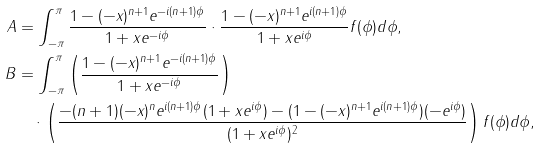Convert formula to latex. <formula><loc_0><loc_0><loc_500><loc_500>A & = \int _ { - \pi } ^ { \pi } \frac { 1 - ( - x ) ^ { n + 1 } e ^ { - i ( n + 1 ) \phi } } { 1 + x e ^ { - i \phi } } \cdot \frac { 1 - ( - x ) ^ { n + 1 } e ^ { i ( n + 1 ) \phi } } { 1 + x e ^ { i \phi } } f ( \phi ) d \phi , \\ B & = \int _ { - \pi } ^ { \pi } \left ( \frac { 1 - ( - x ) ^ { n + 1 } e ^ { - i ( n + 1 ) \phi } } { 1 + x e ^ { - i \phi } } \right ) \\ & \quad \cdot \left ( \frac { - ( n + 1 ) ( - x ) ^ { n } e ^ { i ( n + 1 ) \phi } ( 1 + x e ^ { i \phi } ) - ( 1 - ( - x ) ^ { n + 1 } e ^ { i ( n + 1 ) \phi } ) ( - e ^ { i \phi } ) } { ( 1 + x e ^ { i \phi } ) ^ { 2 } } \right ) f ( \phi ) d \phi ,</formula> 